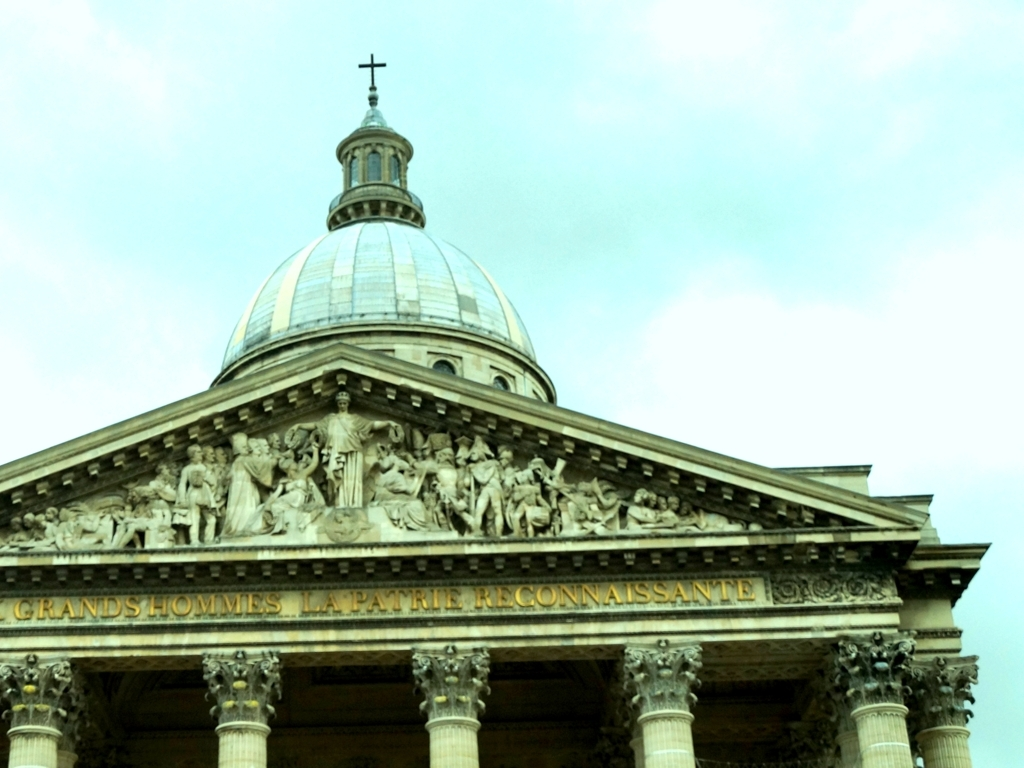Is the color balance perfect in this image? The color balance in the image appears to be slightly off, with a greenish tint that may not accurately represent the true colors of the scene. This could be a result of the camera settings or the lighting conditions at the time the photo was taken. Adjusting the white balance and color correction could improve the fidelity of the image's representation. 